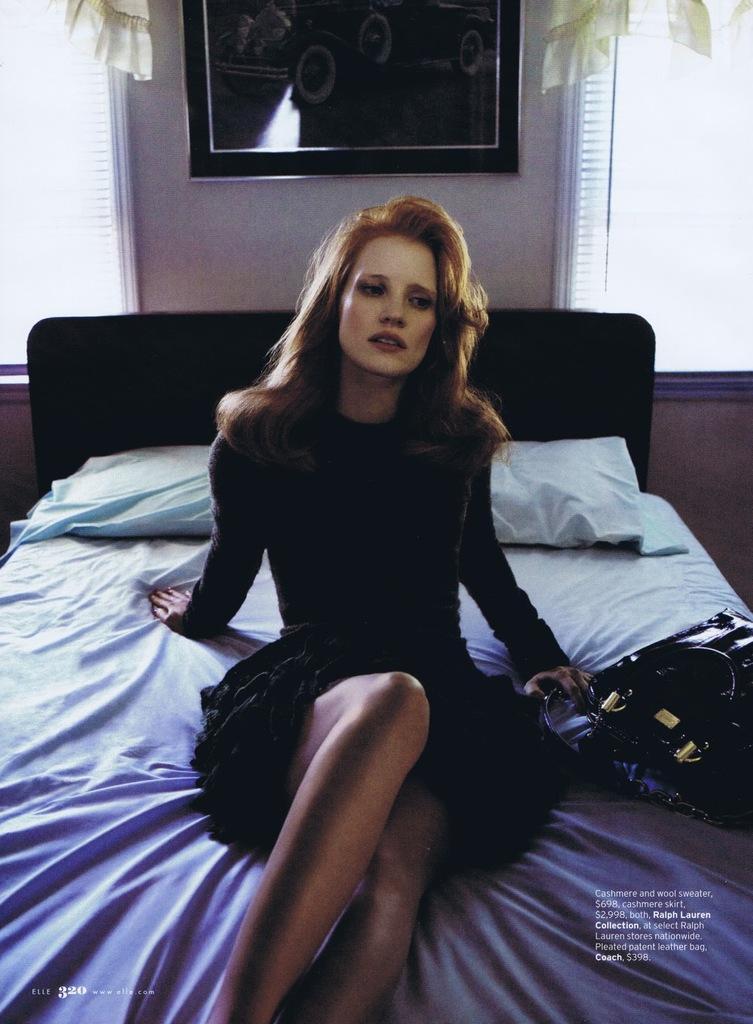Can you describe this image briefly? In the image one lady wearing a black dress is sitting on a bed. She is holding a bag. There are pillows on the bed. In the background there is a photo frame hanged on the wall and window with window blinds. 